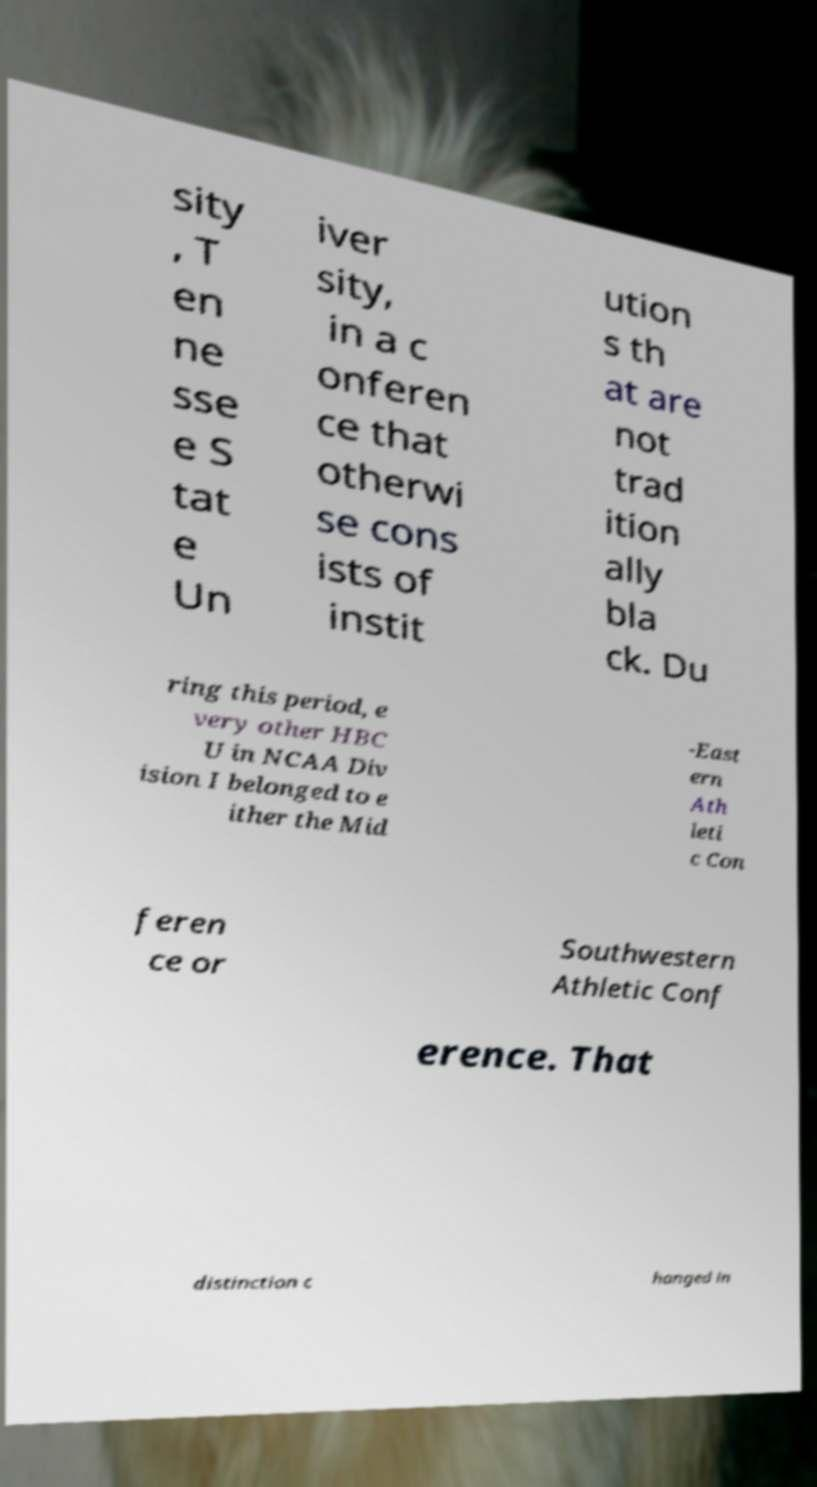I need the written content from this picture converted into text. Can you do that? sity , T en ne sse e S tat e Un iver sity, in a c onferen ce that otherwi se cons ists of instit ution s th at are not trad ition ally bla ck. Du ring this period, e very other HBC U in NCAA Div ision I belonged to e ither the Mid -East ern Ath leti c Con feren ce or Southwestern Athletic Conf erence. That distinction c hanged in 